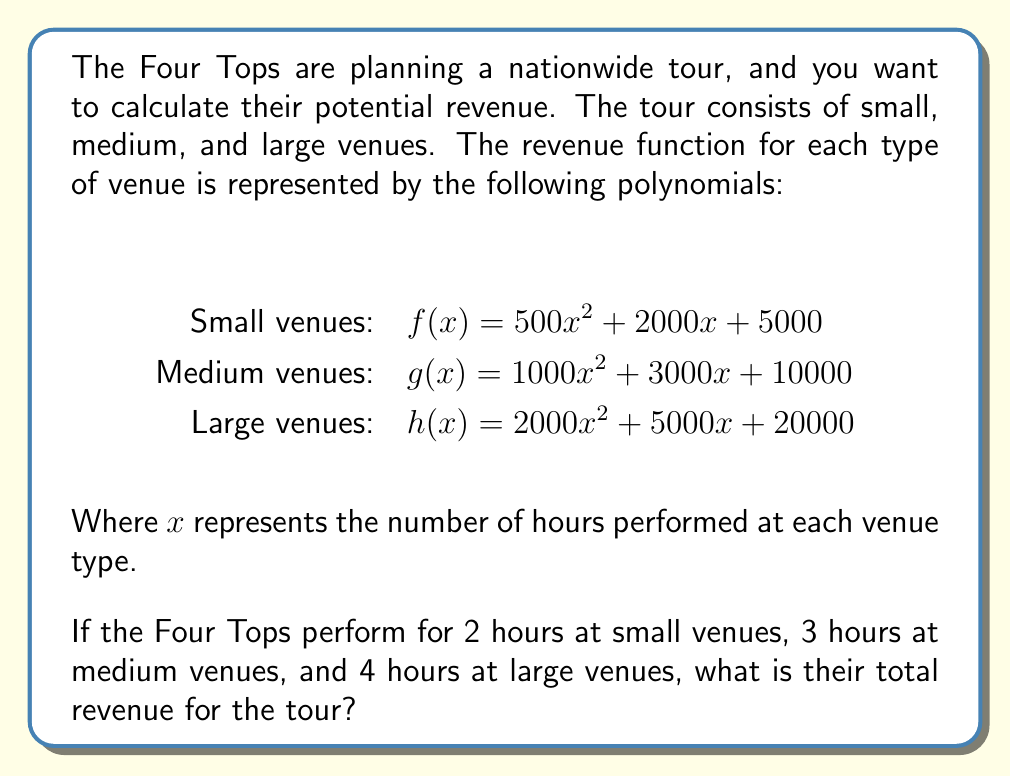Show me your answer to this math problem. To solve this problem, we need to evaluate each polynomial function at the given number of hours and then sum the results. Let's break it down step-by-step:

1. Small venues revenue (2 hours):
   $f(2) = 500(2)^2 + 2000(2) + 5000$
   $= 500(4) + 4000 + 5000$
   $= 2000 + 4000 + 5000$
   $= 11000$

2. Medium venues revenue (3 hours):
   $g(3) = 1000(3)^2 + 3000(3) + 10000$
   $= 1000(9) + 9000 + 10000$
   $= 9000 + 9000 + 10000$
   $= 28000$

3. Large venues revenue (4 hours):
   $h(4) = 2000(4)^2 + 5000(4) + 20000$
   $= 2000(16) + 20000 + 20000$
   $= 32000 + 20000 + 20000$
   $= 72000$

4. Total revenue:
   Sum the revenues from all venue types:
   $11000 + 28000 + 72000 = 111000$

Therefore, the total revenue for the Four Tops tour is $111,000.
Answer: $111,000 